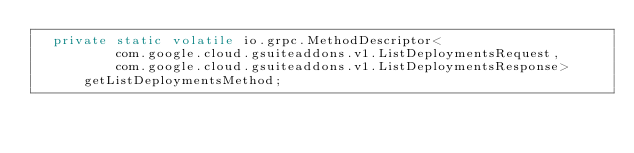Convert code to text. <code><loc_0><loc_0><loc_500><loc_500><_Java_>  private static volatile io.grpc.MethodDescriptor<
          com.google.cloud.gsuiteaddons.v1.ListDeploymentsRequest,
          com.google.cloud.gsuiteaddons.v1.ListDeploymentsResponse>
      getListDeploymentsMethod;
</code> 